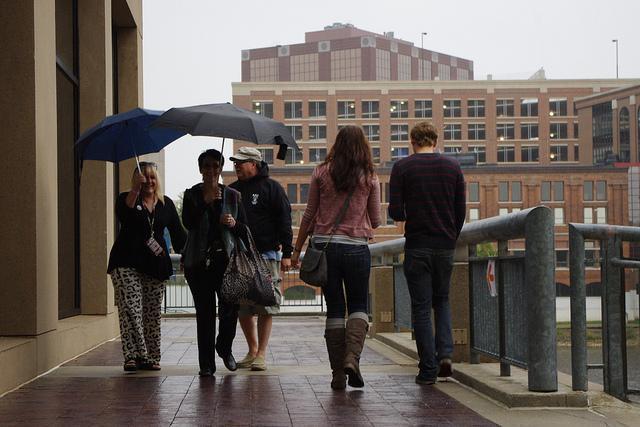What problem are the two people on the right facing?
Select the accurate answer and provide explanation: 'Answer: answer
Rationale: rationale.'
Options: Getting soaked, getting thirsty, getting tired, getting sunburned. Answer: getting soaked.
Rationale: The two people on the right are facing getting wet from the rain that is falling. 